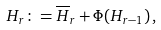<formula> <loc_0><loc_0><loc_500><loc_500>H _ { r } \colon = { \overline { H } _ { r } } + \Phi ( H _ { r - 1 } ) \, ,</formula> 